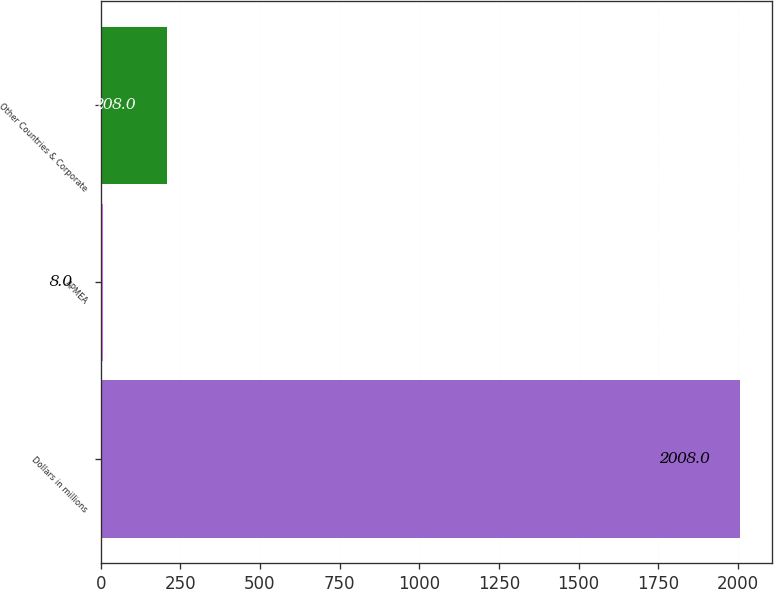Convert chart to OTSL. <chart><loc_0><loc_0><loc_500><loc_500><bar_chart><fcel>Dollars in millions<fcel>APMEA<fcel>Other Countries & Corporate<nl><fcel>2008<fcel>8<fcel>208<nl></chart> 